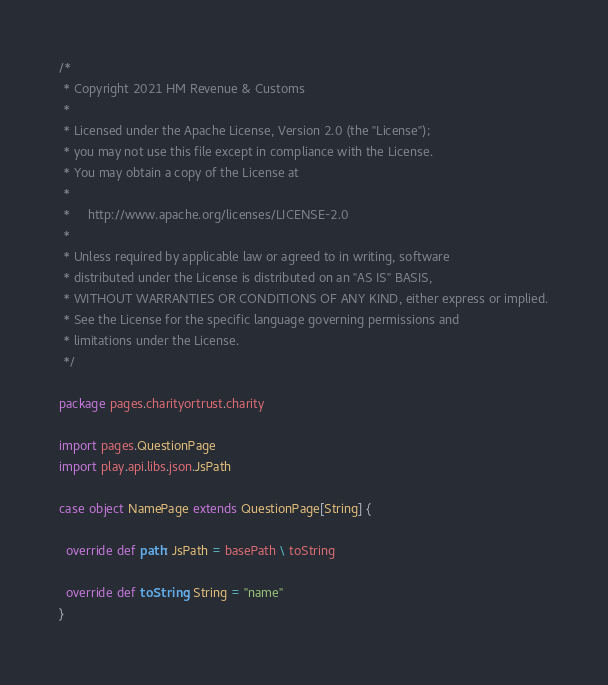Convert code to text. <code><loc_0><loc_0><loc_500><loc_500><_Scala_>/*
 * Copyright 2021 HM Revenue & Customs
 *
 * Licensed under the Apache License, Version 2.0 (the "License");
 * you may not use this file except in compliance with the License.
 * You may obtain a copy of the License at
 *
 *     http://www.apache.org/licenses/LICENSE-2.0
 *
 * Unless required by applicable law or agreed to in writing, software
 * distributed under the License is distributed on an "AS IS" BASIS,
 * WITHOUT WARRANTIES OR CONDITIONS OF ANY KIND, either express or implied.
 * See the License for the specific language governing permissions and
 * limitations under the License.
 */

package pages.charityortrust.charity

import pages.QuestionPage
import play.api.libs.json.JsPath

case object NamePage extends QuestionPage[String] {

  override def path: JsPath = basePath \ toString

  override def toString: String = "name"
}
</code> 